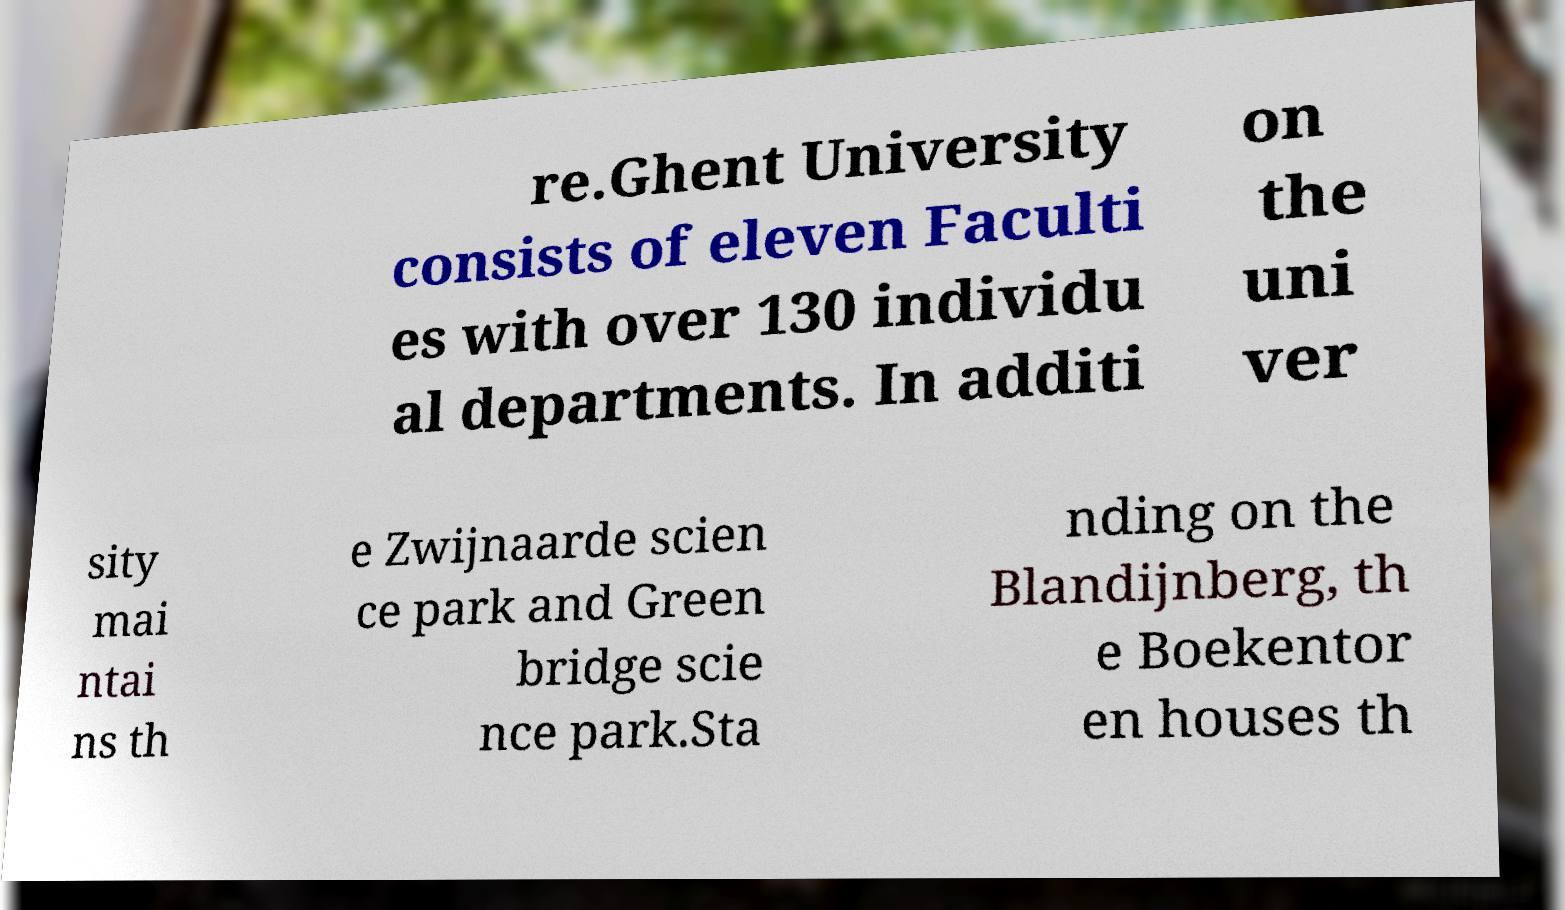There's text embedded in this image that I need extracted. Can you transcribe it verbatim? re.Ghent University consists of eleven Faculti es with over 130 individu al departments. In additi on the uni ver sity mai ntai ns th e Zwijnaarde scien ce park and Green bridge scie nce park.Sta nding on the Blandijnberg, th e Boekentor en houses th 